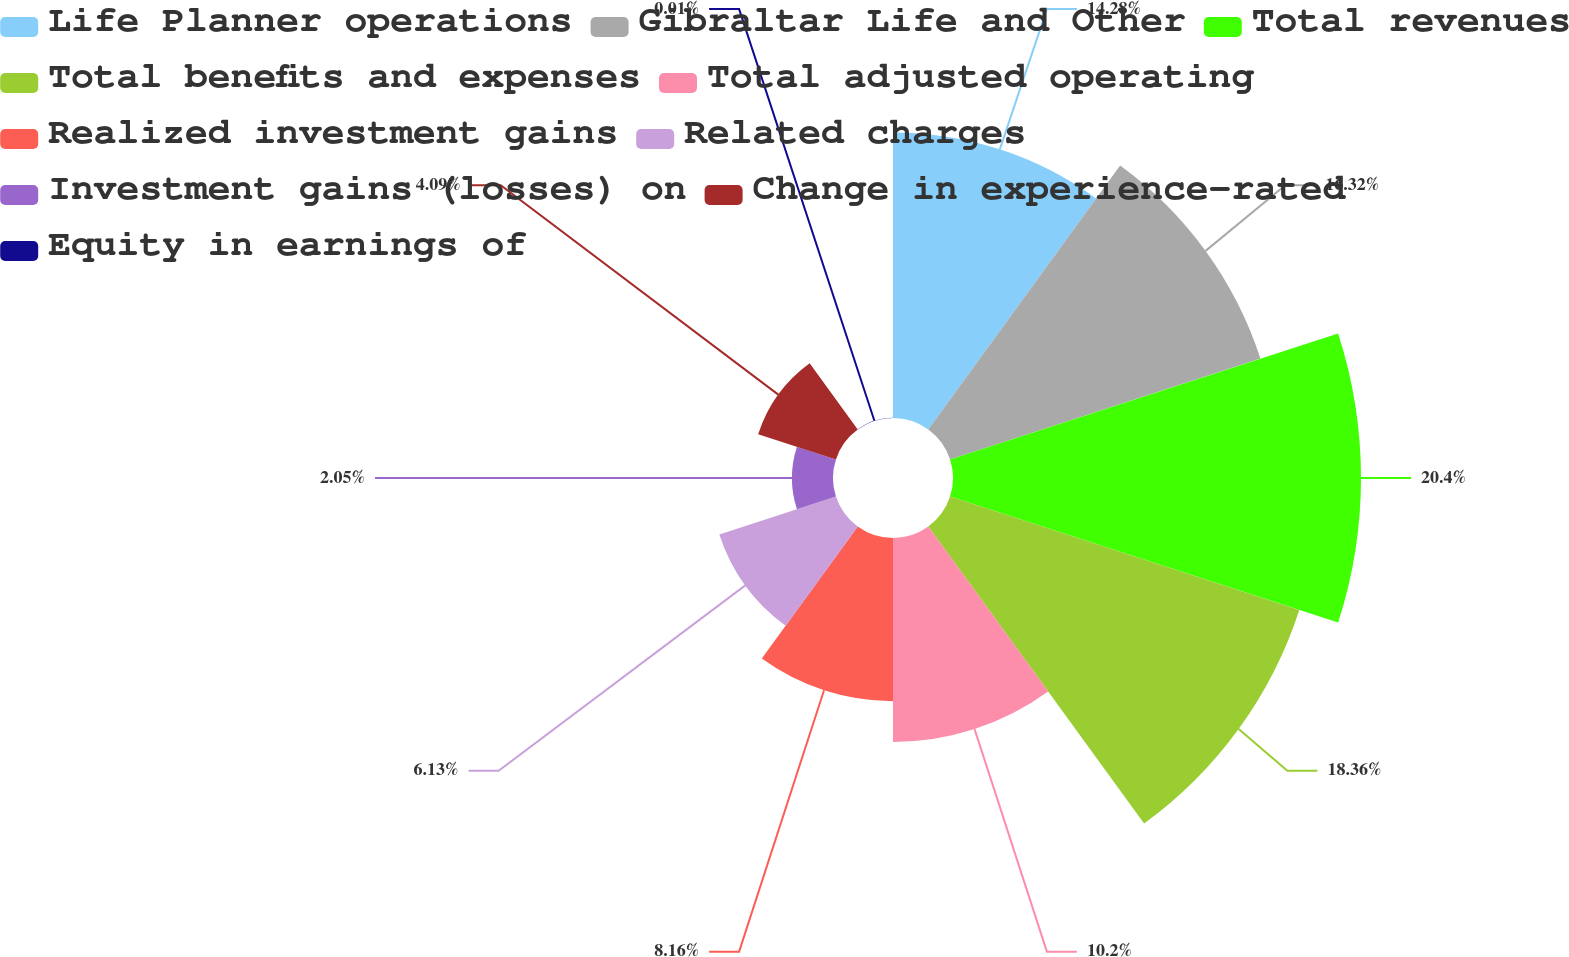Convert chart to OTSL. <chart><loc_0><loc_0><loc_500><loc_500><pie_chart><fcel>Life Planner operations<fcel>Gibraltar Life and Other<fcel>Total revenues<fcel>Total benefits and expenses<fcel>Total adjusted operating<fcel>Realized investment gains<fcel>Related charges<fcel>Investment gains (losses) on<fcel>Change in experience-rated<fcel>Equity in earnings of<nl><fcel>14.28%<fcel>16.32%<fcel>20.4%<fcel>18.36%<fcel>10.2%<fcel>8.16%<fcel>6.13%<fcel>2.05%<fcel>4.09%<fcel>0.01%<nl></chart> 